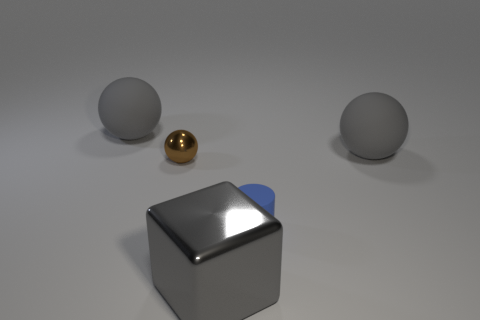Does the object that is in front of the blue rubber object have the same size as the small matte cylinder?
Offer a very short reply. No. There is a large thing that is both on the left side of the tiny blue object and behind the tiny matte cylinder; what color is it?
Offer a very short reply. Gray. Is there a large block behind the gray rubber sphere that is in front of the matte object that is left of the tiny blue matte object?
Make the answer very short. No. What number of things are large brown metal blocks or brown spheres?
Offer a very short reply. 1. Is the material of the tiny cylinder the same as the large gray ball to the left of the brown metal ball?
Give a very brief answer. Yes. Is there any other thing of the same color as the small ball?
Offer a very short reply. No. What number of objects are spheres that are behind the metallic ball or things that are behind the brown metal thing?
Provide a succinct answer. 2. What shape is the thing that is behind the small blue cylinder and to the right of the gray metal thing?
Offer a very short reply. Sphere. What number of rubber spheres are in front of the tiny thing left of the blue object?
Make the answer very short. 0. Is there any other thing that has the same material as the big gray block?
Provide a short and direct response. Yes. 